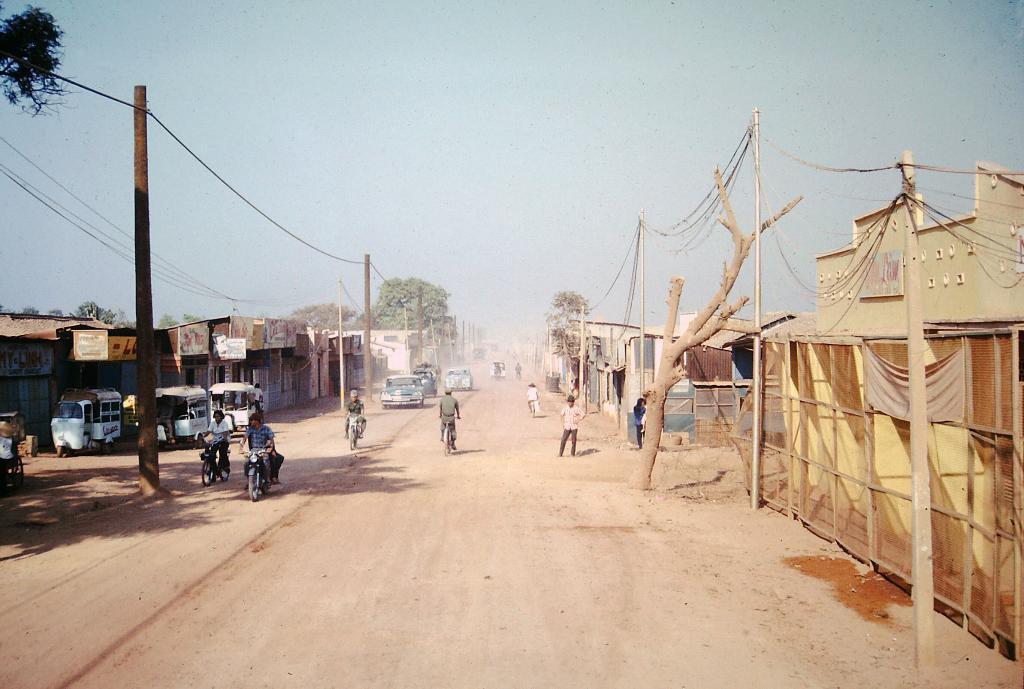Can you describe this image briefly? It is the outside view. In this image, we can see few houses, poles, trees, wires, people's, vehicles. Few people are riding vehicles on the road. Top of the image, there is a sky. 